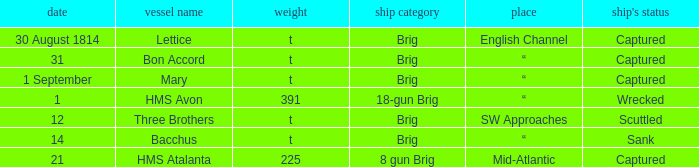With a tonnage of 225 what is the ship type? 8 gun Brig. 